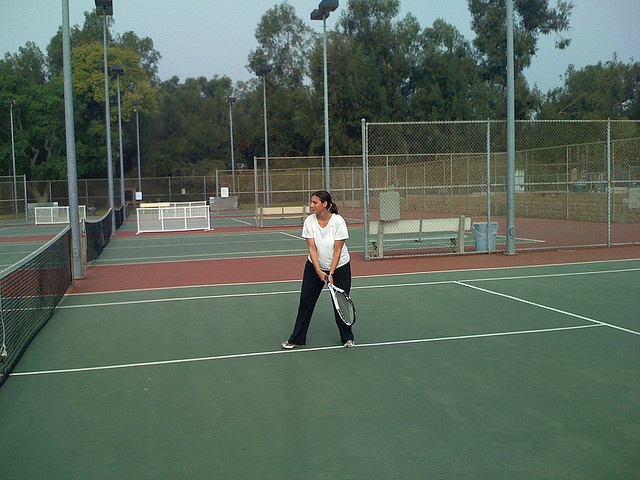Describe the objects in this image and their specific colors. I can see people in lightblue, black, white, brown, and salmon tones, bench in lightblue, darkgray, gray, and lightgray tones, bench in lightblue, tan, and gray tones, tennis racket in lightblue, gray, black, darkgray, and white tones, and bench in lightblue, beige, khaki, and tan tones in this image. 